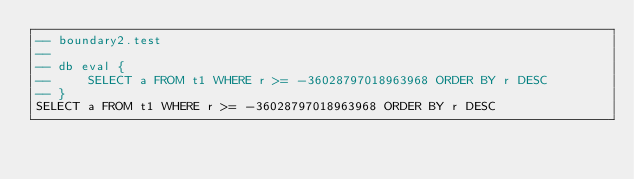Convert code to text. <code><loc_0><loc_0><loc_500><loc_500><_SQL_>-- boundary2.test
-- 
-- db eval {
--     SELECT a FROM t1 WHERE r >= -36028797018963968 ORDER BY r DESC
-- }
SELECT a FROM t1 WHERE r >= -36028797018963968 ORDER BY r DESC</code> 